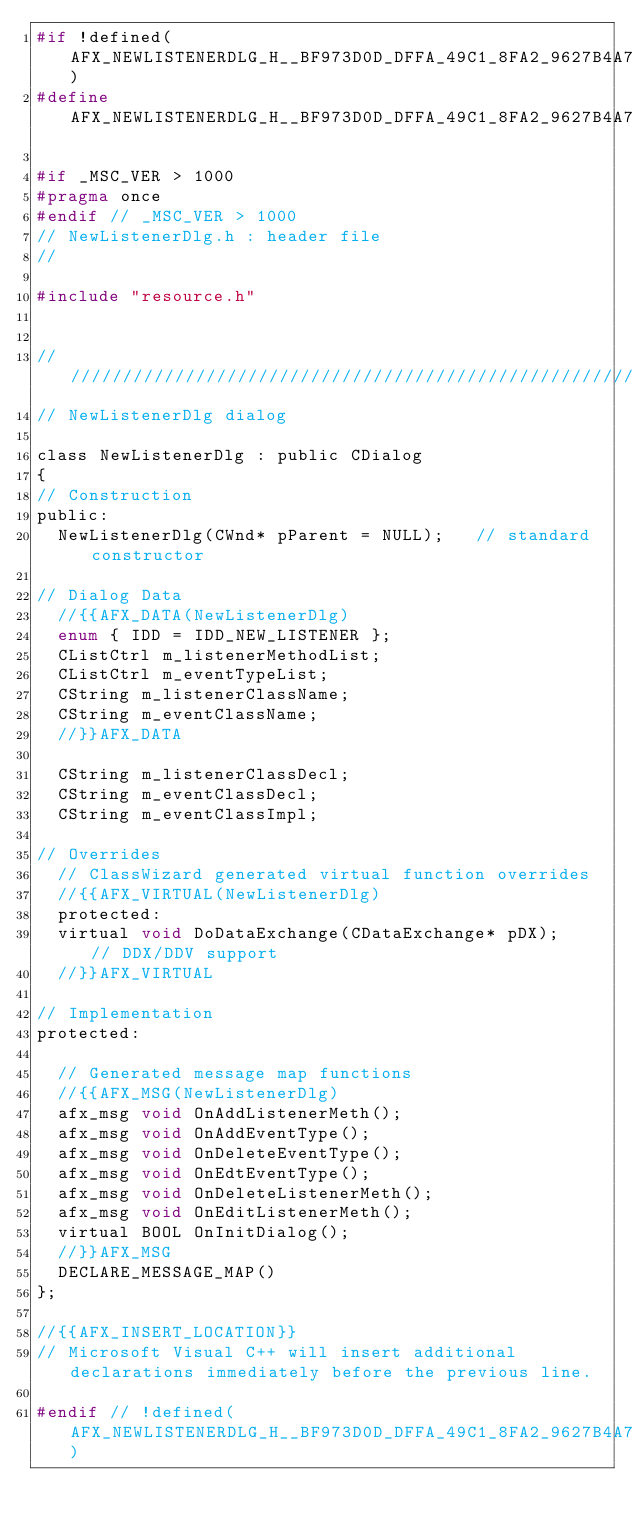<code> <loc_0><loc_0><loc_500><loc_500><_C_>#if !defined(AFX_NEWLISTENERDLG_H__BF973D0D_DFFA_49C1_8FA2_9627B4A7DE4D__INCLUDED_)
#define AFX_NEWLISTENERDLG_H__BF973D0D_DFFA_49C1_8FA2_9627B4A7DE4D__INCLUDED_

#if _MSC_VER > 1000
#pragma once
#endif // _MSC_VER > 1000
// NewListenerDlg.h : header file
//

#include "resource.h"


/////////////////////////////////////////////////////////////////////////////
// NewListenerDlg dialog

class NewListenerDlg : public CDialog
{
// Construction
public:
	NewListenerDlg(CWnd* pParent = NULL);   // standard constructor

// Dialog Data
	//{{AFX_DATA(NewListenerDlg)
	enum { IDD = IDD_NEW_LISTENER };
	CListCtrl	m_listenerMethodList;
	CListCtrl	m_eventTypeList;
	CString	m_listenerClassName;
	CString	m_eventClassName;
	//}}AFX_DATA

	CString m_listenerClassDecl;
	CString m_eventClassDecl;
	CString m_eventClassImpl;

// Overrides
	// ClassWizard generated virtual function overrides
	//{{AFX_VIRTUAL(NewListenerDlg)
	protected:
	virtual void DoDataExchange(CDataExchange* pDX);    // DDX/DDV support
	//}}AFX_VIRTUAL

// Implementation
protected:

	// Generated message map functions
	//{{AFX_MSG(NewListenerDlg)
	afx_msg void OnAddListenerMeth();
	afx_msg void OnAddEventType();
	afx_msg void OnDeleteEventType();
	afx_msg void OnEdtEventType();
	afx_msg void OnDeleteListenerMeth();
	afx_msg void OnEditListenerMeth();
	virtual BOOL OnInitDialog();
	//}}AFX_MSG
	DECLARE_MESSAGE_MAP()
};

//{{AFX_INSERT_LOCATION}}
// Microsoft Visual C++ will insert additional declarations immediately before the previous line.

#endif // !defined(AFX_NEWLISTENERDLG_H__BF973D0D_DFFA_49C1_8FA2_9627B4A7DE4D__INCLUDED_)
</code> 